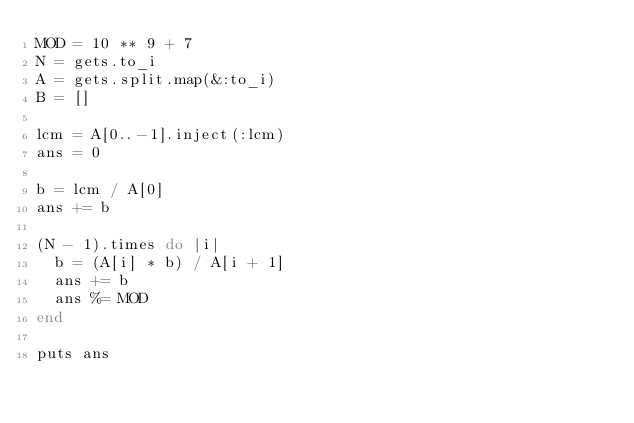Convert code to text. <code><loc_0><loc_0><loc_500><loc_500><_Ruby_>MOD = 10 ** 9 + 7
N = gets.to_i
A = gets.split.map(&:to_i)
B = []

lcm = A[0..-1].inject(:lcm)
ans = 0

b = lcm / A[0]
ans += b

(N - 1).times do |i|
  b = (A[i] * b) / A[i + 1]
  ans += b
  ans %= MOD
end

puts ans
</code> 